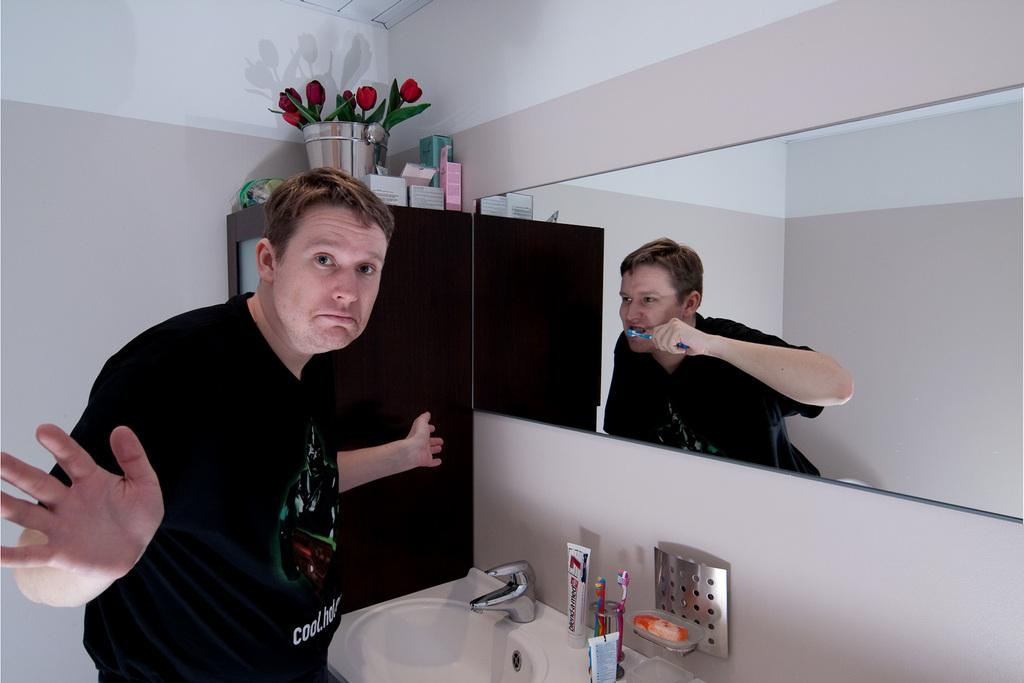<image>
Render a clear and concise summary of the photo. A man wearing a black shirt with writing on it beginning with the word cool, is facing the direction opposite the roses with his arms out. 